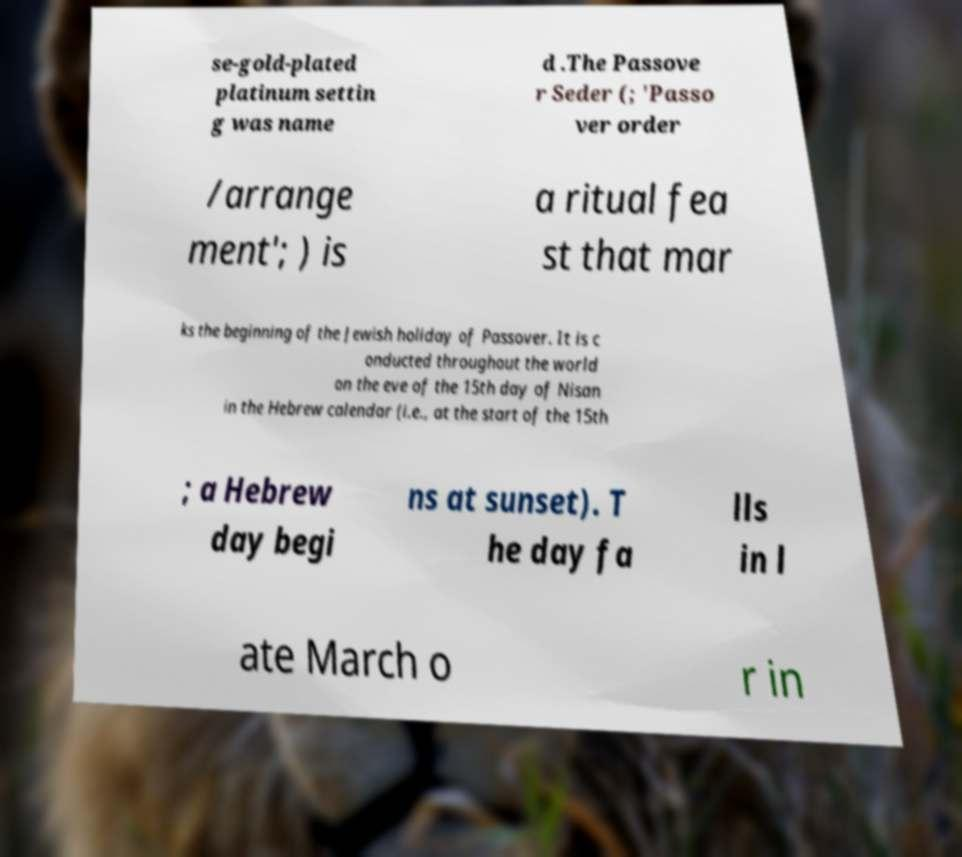Could you assist in decoding the text presented in this image and type it out clearly? se-gold-plated platinum settin g was name d .The Passove r Seder (; 'Passo ver order /arrange ment'; ) is a ritual fea st that mar ks the beginning of the Jewish holiday of Passover. It is c onducted throughout the world on the eve of the 15th day of Nisan in the Hebrew calendar (i.e., at the start of the 15th ; a Hebrew day begi ns at sunset). T he day fa lls in l ate March o r in 